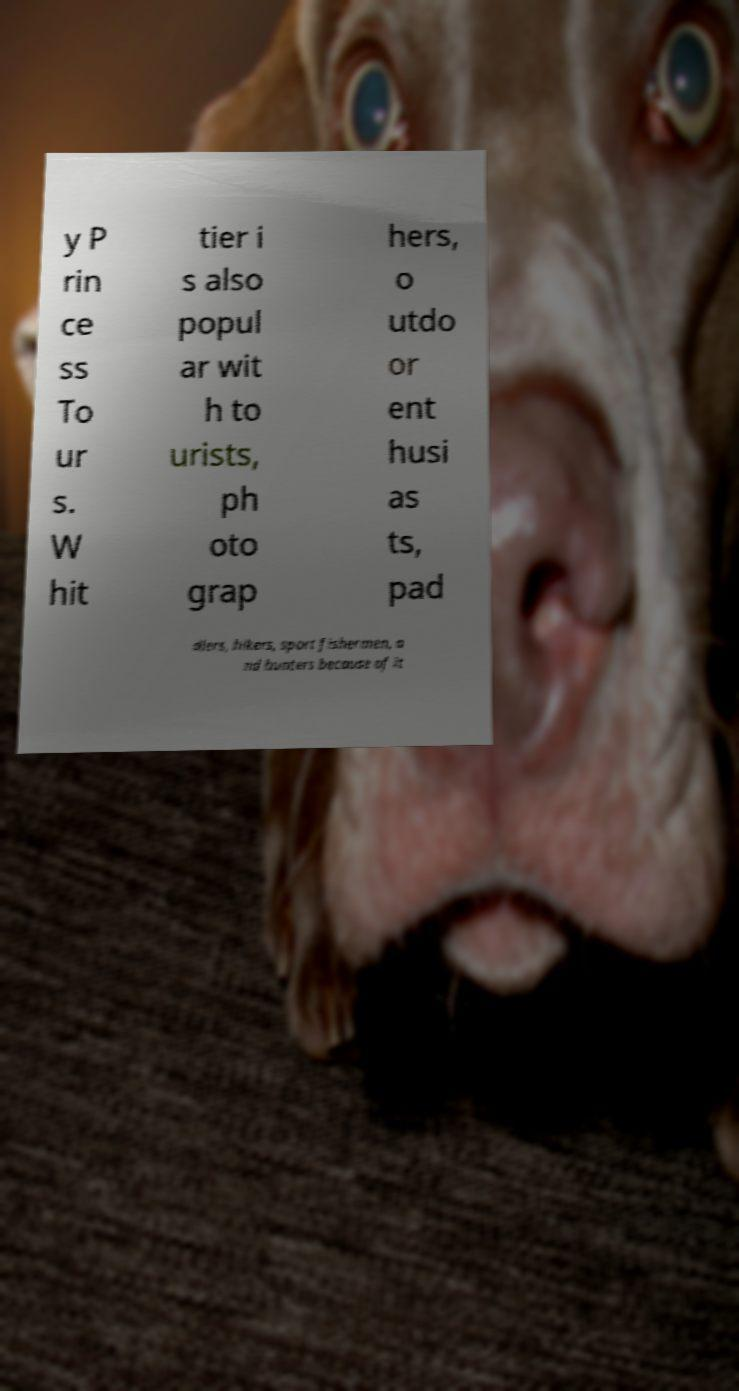Can you read and provide the text displayed in the image?This photo seems to have some interesting text. Can you extract and type it out for me? y P rin ce ss To ur s. W hit tier i s also popul ar wit h to urists, ph oto grap hers, o utdo or ent husi as ts, pad dlers, hikers, sport fishermen, a nd hunters because of it 